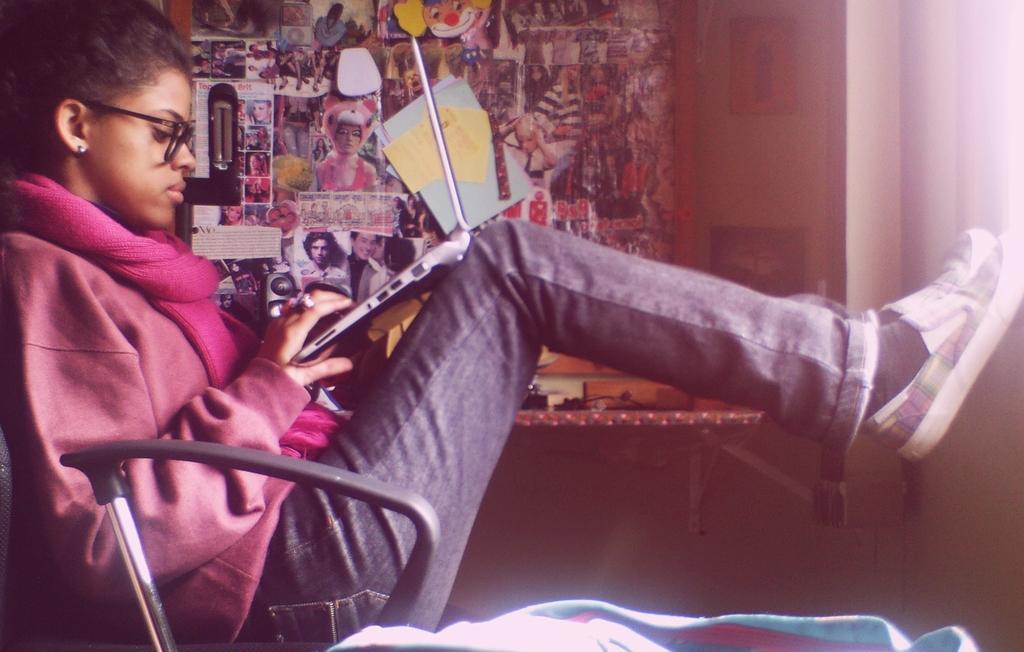Please provide a concise description of this image. In the foreground of this image, there is a woman sitting on the chair holding a laptop and resting legs on the wall. In the background, there are photos, posters, few papers on the wall and also we can see few objects on the wall desk. 